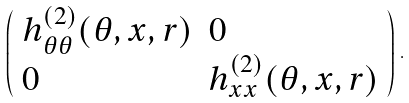<formula> <loc_0><loc_0><loc_500><loc_500>\left ( \begin{array} { l l } h ^ { ( 2 ) } _ { \theta \theta } ( \theta , x , r ) & 0 \\ 0 & h ^ { ( 2 ) } _ { x x } ( \theta , x , r ) \end{array} \right ) \, .</formula> 